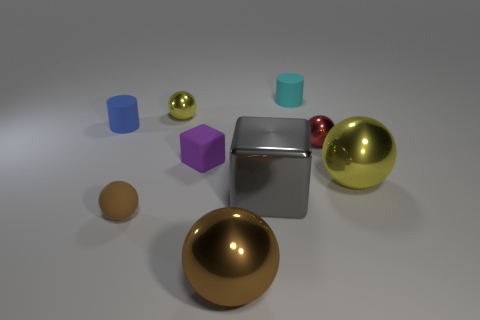Subtract all tiny yellow balls. How many balls are left? 4 Subtract all yellow cylinders. How many yellow spheres are left? 2 Subtract 1 balls. How many balls are left? 4 Subtract all brown balls. How many balls are left? 3 Subtract all blue cylinders. Subtract all purple blocks. How many cylinders are left? 1 Subtract all big things. Subtract all gray matte things. How many objects are left? 6 Add 4 purple blocks. How many purple blocks are left? 5 Add 1 yellow shiny cylinders. How many yellow shiny cylinders exist? 1 Subtract 0 brown cylinders. How many objects are left? 9 Subtract all cubes. How many objects are left? 7 